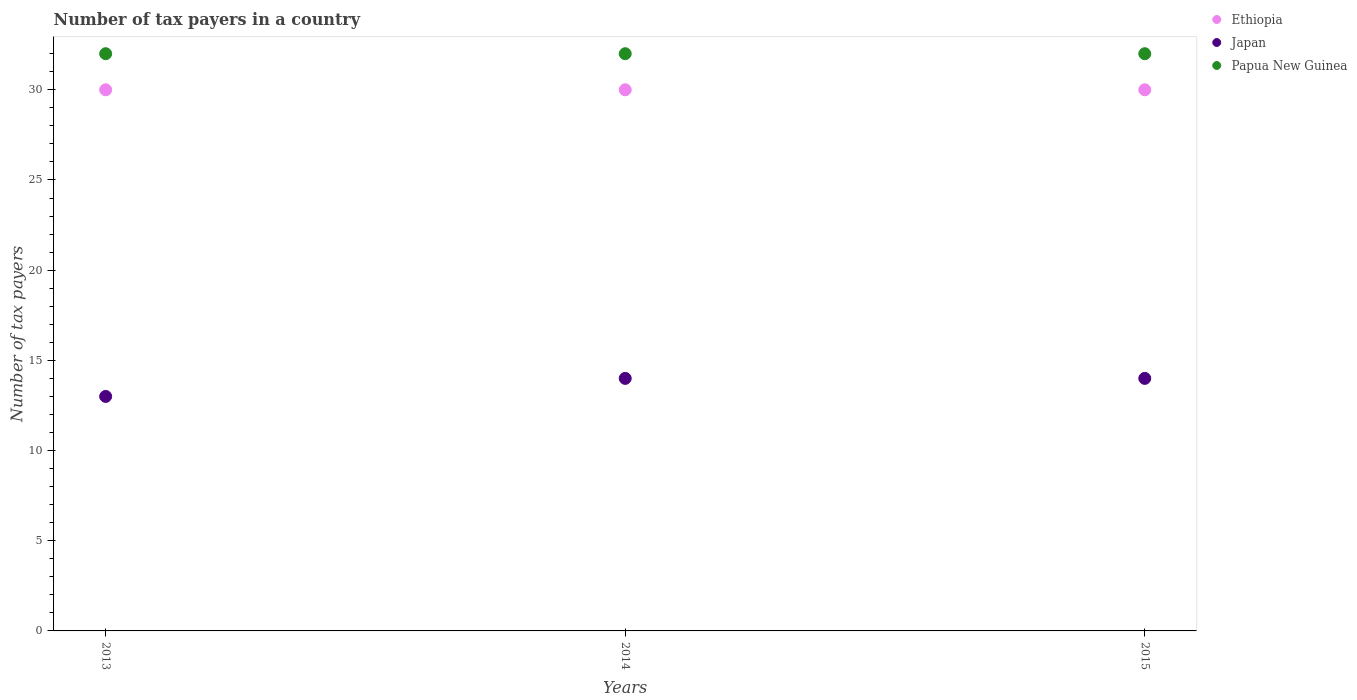How many different coloured dotlines are there?
Ensure brevity in your answer.  3. Is the number of dotlines equal to the number of legend labels?
Give a very brief answer. Yes. What is the number of tax payers in in Japan in 2013?
Keep it short and to the point. 13. Across all years, what is the maximum number of tax payers in in Japan?
Make the answer very short. 14. In which year was the number of tax payers in in Japan maximum?
Provide a succinct answer. 2014. In which year was the number of tax payers in in Japan minimum?
Your response must be concise. 2013. What is the difference between the number of tax payers in in Japan in 2015 and the number of tax payers in in Ethiopia in 2013?
Offer a terse response. -16. What is the average number of tax payers in in Japan per year?
Make the answer very short. 13.67. In the year 2013, what is the difference between the number of tax payers in in Papua New Guinea and number of tax payers in in Ethiopia?
Your response must be concise. 2. In how many years, is the number of tax payers in in Ethiopia greater than 15?
Your response must be concise. 3. Is the number of tax payers in in Papua New Guinea in 2013 less than that in 2015?
Offer a terse response. No. Is the difference between the number of tax payers in in Papua New Guinea in 2013 and 2015 greater than the difference between the number of tax payers in in Ethiopia in 2013 and 2015?
Provide a succinct answer. No. What is the difference between the highest and the second highest number of tax payers in in Japan?
Give a very brief answer. 0. What is the difference between the highest and the lowest number of tax payers in in Ethiopia?
Offer a terse response. 0. In how many years, is the number of tax payers in in Japan greater than the average number of tax payers in in Japan taken over all years?
Offer a terse response. 2. Is the sum of the number of tax payers in in Papua New Guinea in 2013 and 2014 greater than the maximum number of tax payers in in Japan across all years?
Offer a very short reply. Yes. Does the number of tax payers in in Japan monotonically increase over the years?
Provide a succinct answer. No. Is the number of tax payers in in Japan strictly greater than the number of tax payers in in Ethiopia over the years?
Your answer should be very brief. No. How many dotlines are there?
Provide a short and direct response. 3. Are the values on the major ticks of Y-axis written in scientific E-notation?
Keep it short and to the point. No. How many legend labels are there?
Give a very brief answer. 3. How are the legend labels stacked?
Ensure brevity in your answer.  Vertical. What is the title of the graph?
Your answer should be very brief. Number of tax payers in a country. What is the label or title of the Y-axis?
Your answer should be very brief. Number of tax payers. What is the Number of tax payers in Papua New Guinea in 2014?
Your answer should be compact. 32. What is the Number of tax payers of Ethiopia in 2015?
Give a very brief answer. 30. What is the Number of tax payers in Japan in 2015?
Your answer should be very brief. 14. Across all years, what is the maximum Number of tax payers in Ethiopia?
Ensure brevity in your answer.  30. Across all years, what is the maximum Number of tax payers of Japan?
Provide a short and direct response. 14. Across all years, what is the maximum Number of tax payers of Papua New Guinea?
Your answer should be compact. 32. Across all years, what is the minimum Number of tax payers in Japan?
Offer a terse response. 13. Across all years, what is the minimum Number of tax payers in Papua New Guinea?
Your response must be concise. 32. What is the total Number of tax payers in Ethiopia in the graph?
Make the answer very short. 90. What is the total Number of tax payers of Papua New Guinea in the graph?
Offer a terse response. 96. What is the difference between the Number of tax payers in Ethiopia in 2013 and that in 2014?
Your response must be concise. 0. What is the difference between the Number of tax payers of Papua New Guinea in 2013 and that in 2014?
Provide a succinct answer. 0. What is the difference between the Number of tax payers of Ethiopia in 2013 and that in 2015?
Provide a succinct answer. 0. What is the difference between the Number of tax payers of Japan in 2013 and that in 2015?
Offer a terse response. -1. What is the difference between the Number of tax payers of Japan in 2014 and that in 2015?
Ensure brevity in your answer.  0. What is the difference between the Number of tax payers of Ethiopia in 2013 and the Number of tax payers of Japan in 2014?
Offer a terse response. 16. What is the difference between the Number of tax payers of Japan in 2013 and the Number of tax payers of Papua New Guinea in 2014?
Make the answer very short. -19. What is the difference between the Number of tax payers of Ethiopia in 2013 and the Number of tax payers of Japan in 2015?
Provide a succinct answer. 16. What is the difference between the Number of tax payers in Ethiopia in 2013 and the Number of tax payers in Papua New Guinea in 2015?
Provide a short and direct response. -2. What is the difference between the Number of tax payers of Japan in 2013 and the Number of tax payers of Papua New Guinea in 2015?
Provide a short and direct response. -19. What is the difference between the Number of tax payers in Ethiopia in 2014 and the Number of tax payers in Japan in 2015?
Ensure brevity in your answer.  16. What is the difference between the Number of tax payers in Ethiopia in 2014 and the Number of tax payers in Papua New Guinea in 2015?
Ensure brevity in your answer.  -2. What is the average Number of tax payers in Japan per year?
Give a very brief answer. 13.67. In the year 2013, what is the difference between the Number of tax payers of Ethiopia and Number of tax payers of Japan?
Give a very brief answer. 17. In the year 2014, what is the difference between the Number of tax payers of Ethiopia and Number of tax payers of Japan?
Give a very brief answer. 16. In the year 2014, what is the difference between the Number of tax payers of Ethiopia and Number of tax payers of Papua New Guinea?
Keep it short and to the point. -2. In the year 2015, what is the difference between the Number of tax payers in Ethiopia and Number of tax payers in Japan?
Keep it short and to the point. 16. What is the ratio of the Number of tax payers of Ethiopia in 2013 to that in 2014?
Keep it short and to the point. 1. What is the ratio of the Number of tax payers in Japan in 2013 to that in 2014?
Provide a short and direct response. 0.93. What is the ratio of the Number of tax payers of Papua New Guinea in 2013 to that in 2014?
Give a very brief answer. 1. What is the ratio of the Number of tax payers in Japan in 2014 to that in 2015?
Offer a very short reply. 1. What is the ratio of the Number of tax payers in Papua New Guinea in 2014 to that in 2015?
Provide a succinct answer. 1. What is the difference between the highest and the second highest Number of tax payers of Papua New Guinea?
Ensure brevity in your answer.  0. 